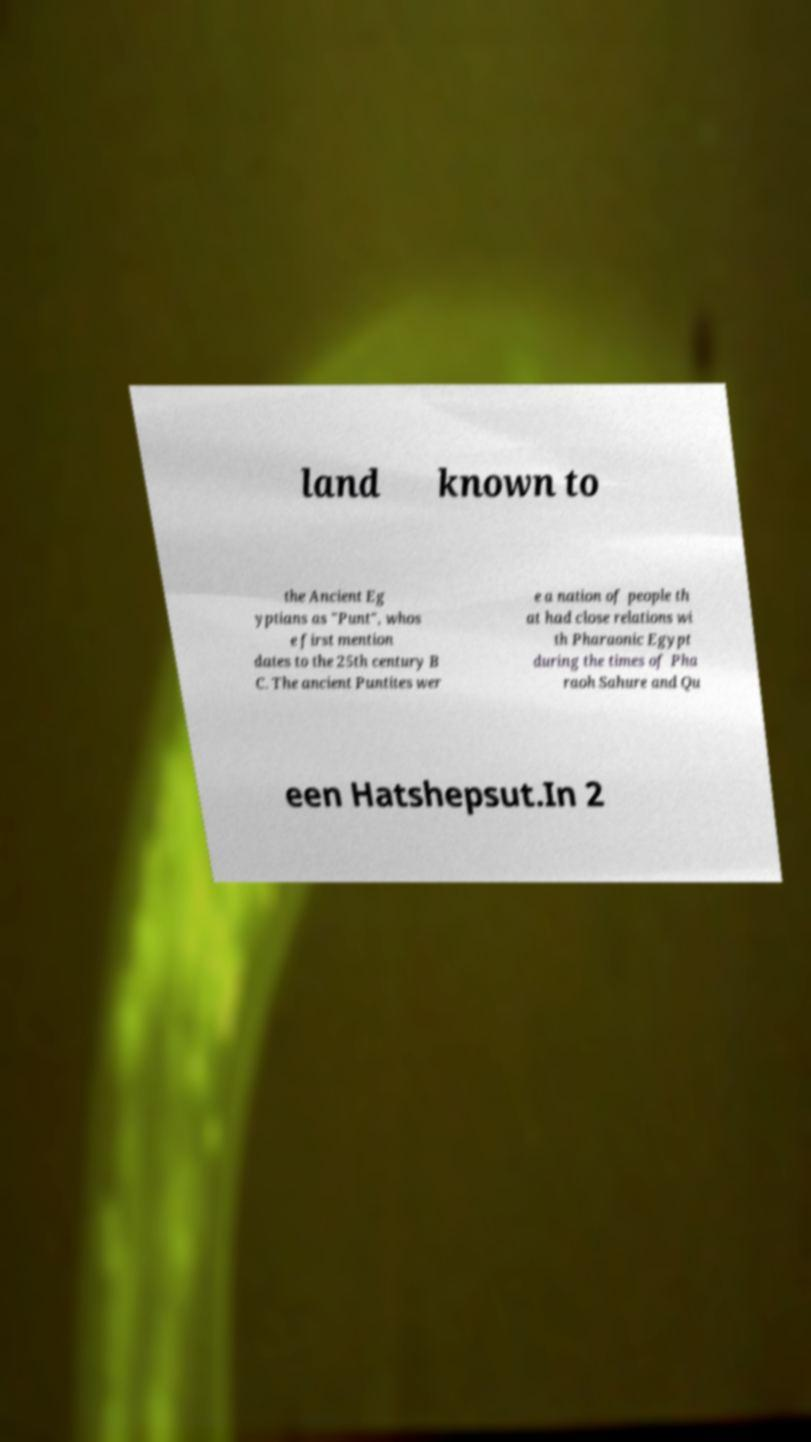There's text embedded in this image that I need extracted. Can you transcribe it verbatim? land known to the Ancient Eg yptians as "Punt", whos e first mention dates to the 25th century B C. The ancient Puntites wer e a nation of people th at had close relations wi th Pharaonic Egypt during the times of Pha raoh Sahure and Qu een Hatshepsut.In 2 